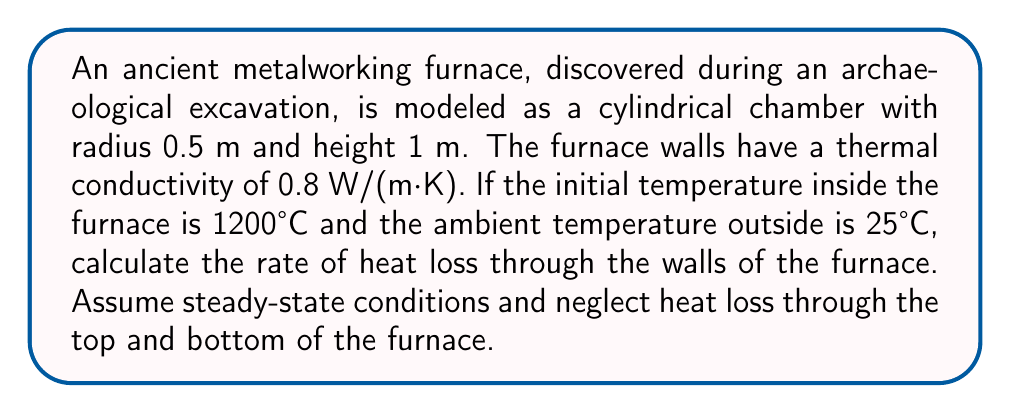Help me with this question. To solve this problem, we'll use Fourier's law of heat conduction for a cylindrical geometry. The steps are as follows:

1) The heat transfer rate through a cylindrical wall is given by:

   $$Q = \frac{2\pi kL(T_i - T_o)}{\ln(r_o/r_i)}$$

   Where:
   $Q$ = heat transfer rate (W)
   $k$ = thermal conductivity (W/(m·K))
   $L$ = length of the cylinder (m)
   $T_i$ = inside temperature (°C)
   $T_o$ = outside temperature (°C)
   $r_o$ = outer radius (m)
   $r_i$ = inner radius (m)

2) We're given:
   $k = 0.8$ W/(m·K)
   $L = 1$ m
   $T_i = 1200°C$
   $T_o = 25°C$
   $r_i = 0.5$ m

3) We need to estimate $r_o$. Let's assume the wall thickness is 0.1 m:
   $r_o = 0.5 + 0.1 = 0.6$ m

4) Now we can substitute these values into our equation:

   $$Q = \frac{2\pi \cdot 0.8 \cdot 1 \cdot (1200 - 25)}{\ln(0.6/0.5)}$$

5) Simplify:
   $$Q = \frac{2\pi \cdot 0.8 \cdot 1175}{\ln(1.2)}$$
   $$Q = \frac{5896.37}{0.1823}$$
   $$Q \approx 32,344.87 \text{ W}$$

6) Round to a reasonable number of significant figures:
   $$Q \approx 32,300 \text{ W}$$
Answer: 32,300 W 